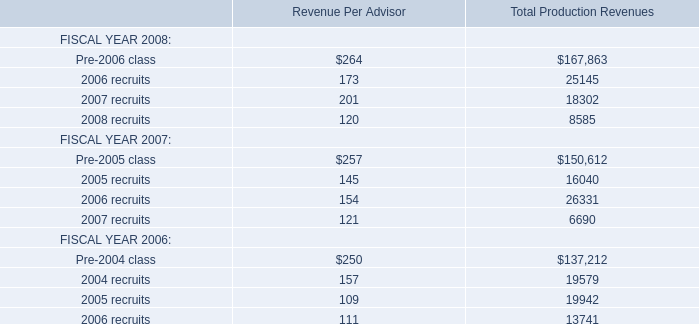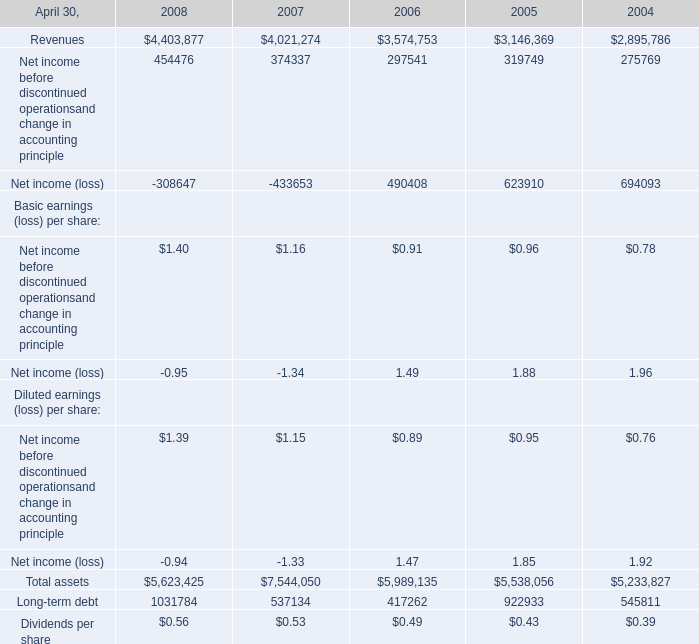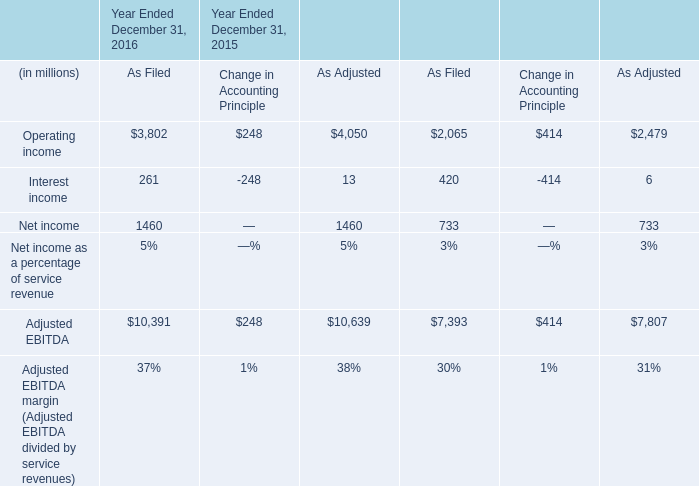What was the value of the Dividends per share at April 30,what year when Long-term debt is greater than 1000000? 
Answer: 0.56. 